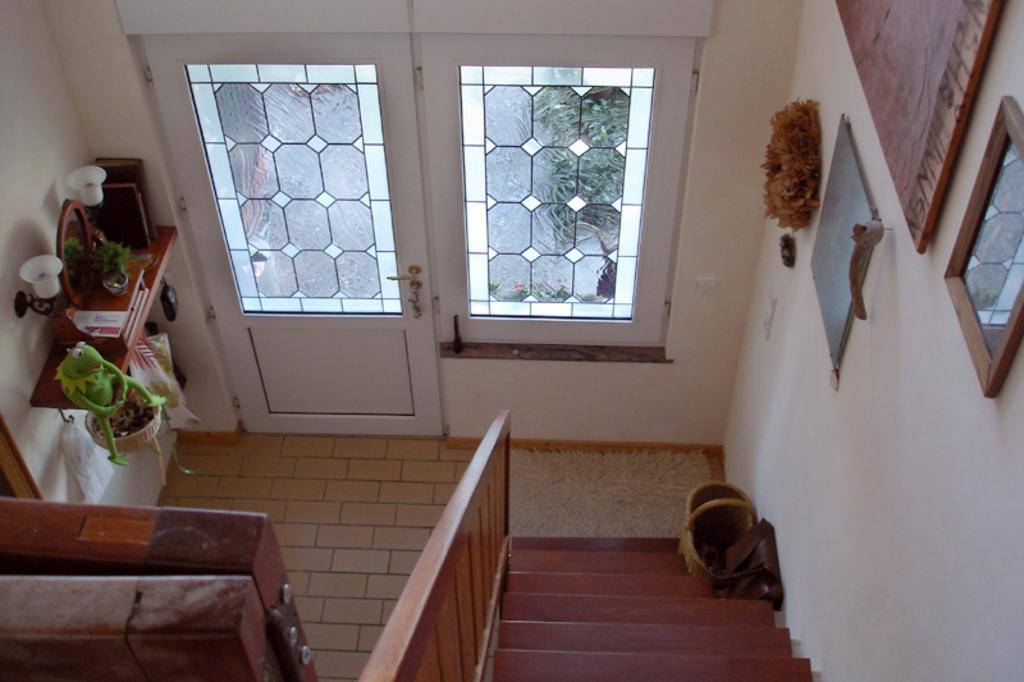What type of architectural feature can be seen in the image? There is a door in the image. What allows natural light to enter the space in the image? There is a window in the image. How can someone access a higher level in the space? There are stairs in the image. What is hanging on the wall in the image? There are frames placed on the wall in the image. What object is used for personal grooming in the image? There is a mirror in the image. What type of plant container is present in the image? There is a flower pot in the image. What type of object is designed for play in the image? There is a toy in the image. How is the toy displayed in the image? The toy is on a stand in the image. What provides illumination in the image? There are lights in the image. What type of deer can be seen grazing in the image? There are no deer present in the image; it features a door, window, stairs, frames, mirror, flower pot, toy, stand, and lights. What achievement is the person in the image celebrating? There is no person present in the image, so it is not possible to determine any achievements being celebrated. 